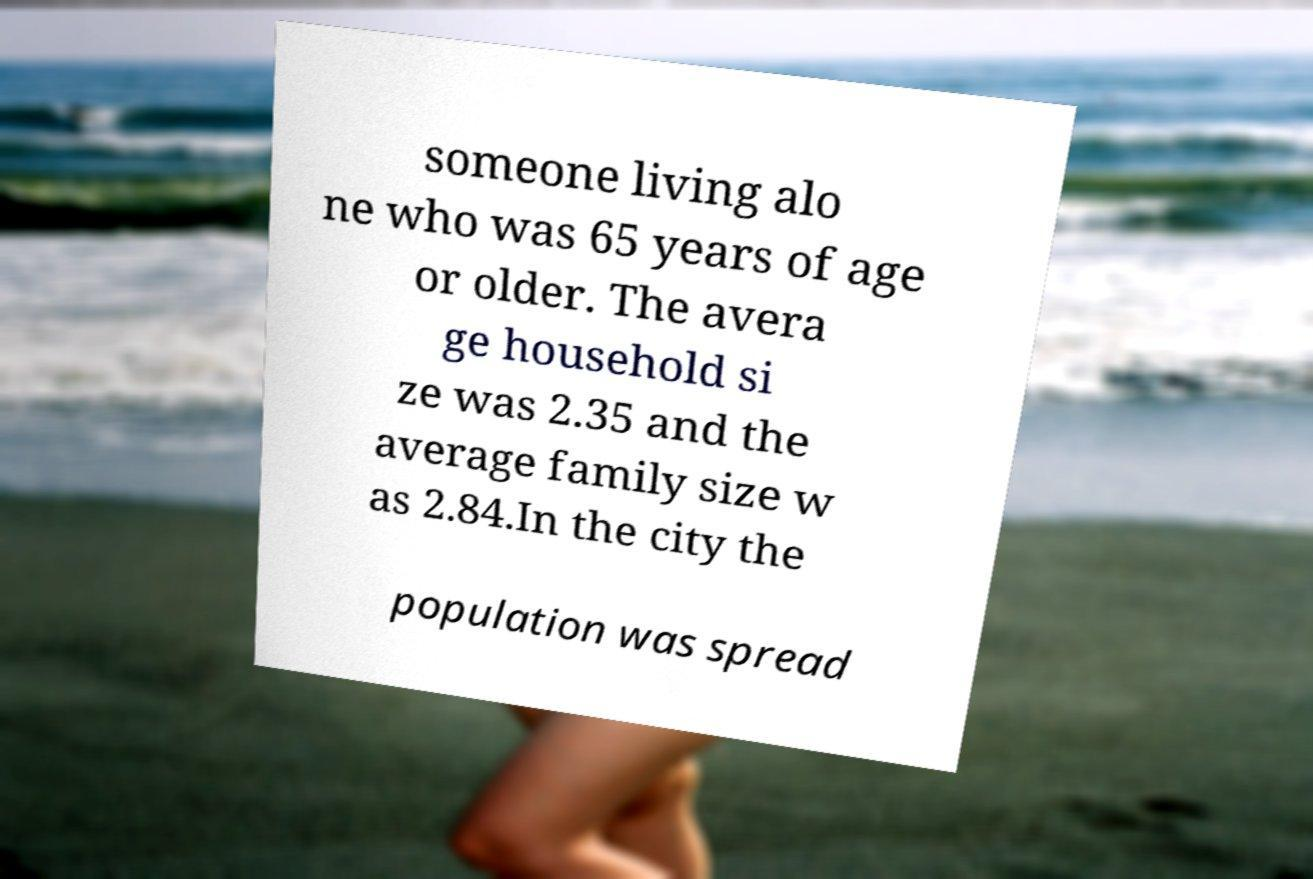Could you extract and type out the text from this image? someone living alo ne who was 65 years of age or older. The avera ge household si ze was 2.35 and the average family size w as 2.84.In the city the population was spread 